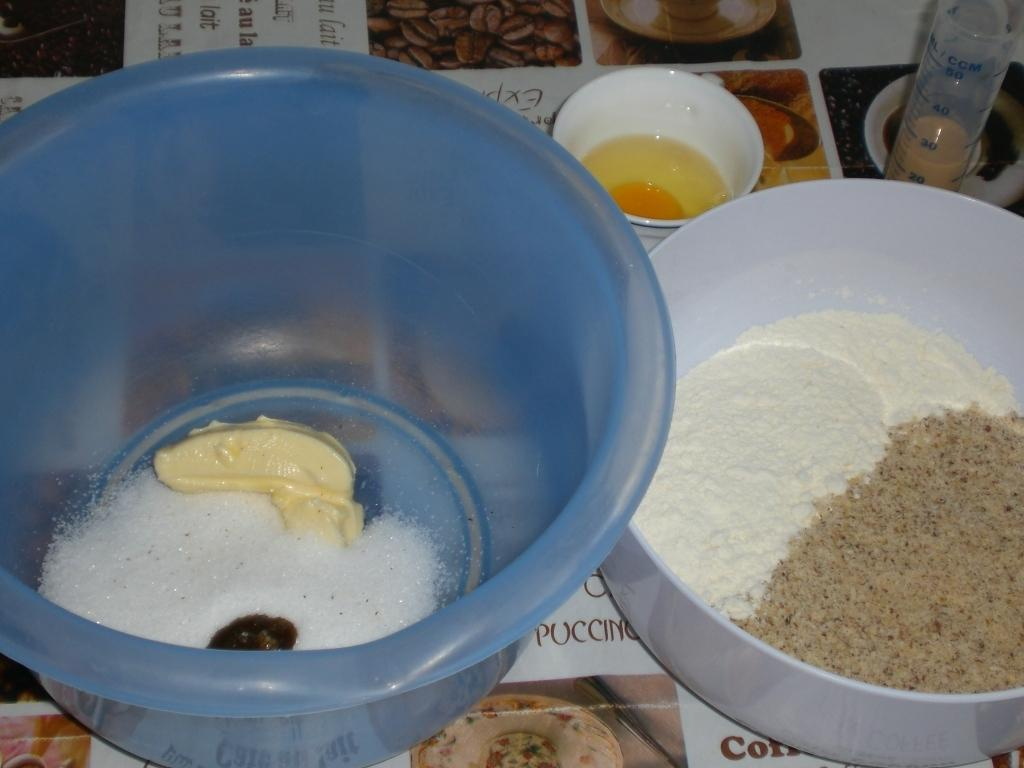How many bowls are on the table in the image? There are three bowls on the table in the image. What is inside the bowls? The bowls contain food ingredients. Can you describe any other objects on the table? There is a tube with liquid in it. What might be used to protect the table from spills or heat? There is a table mat on the table. How many trees can be seen in the image? There are no trees visible in the image. What is the temper of the liquid in the tube? The provided facts do not mention the temperature or state of the liquid in the tube, so it cannot be determined from the image. 